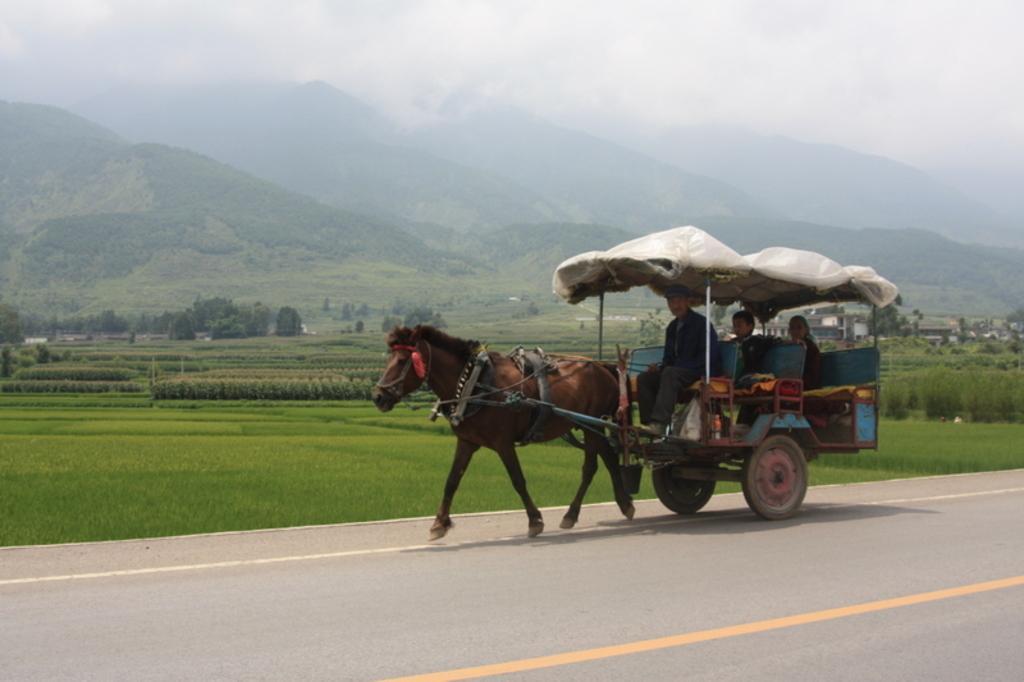How would you summarize this image in a sentence or two? In this image there is a horse with a cart , three persons sitting in the horse cart , and there is grass, plants, trees, houses, hills, and in the background there is sky. 